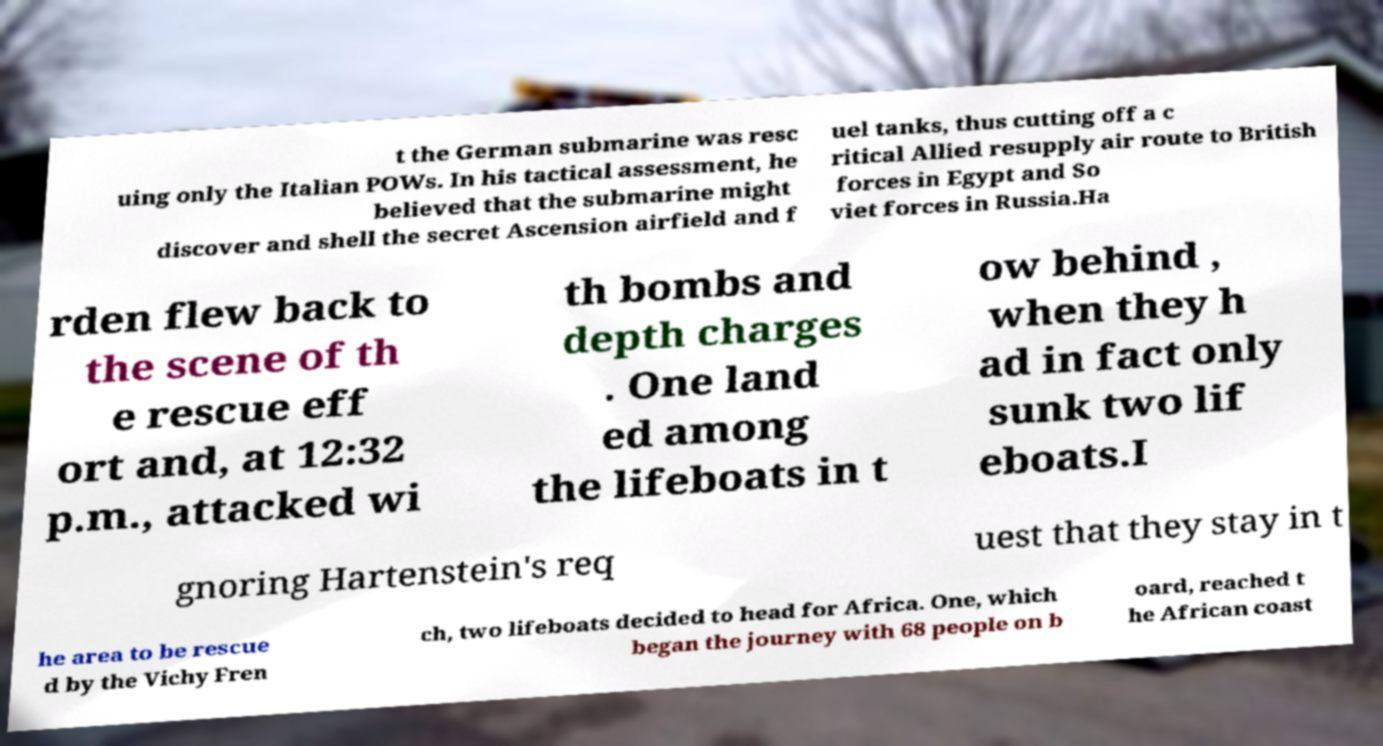Can you read and provide the text displayed in the image?This photo seems to have some interesting text. Can you extract and type it out for me? t the German submarine was resc uing only the Italian POWs. In his tactical assessment, he believed that the submarine might discover and shell the secret Ascension airfield and f uel tanks, thus cutting off a c ritical Allied resupply air route to British forces in Egypt and So viet forces in Russia.Ha rden flew back to the scene of th e rescue eff ort and, at 12:32 p.m., attacked wi th bombs and depth charges . One land ed among the lifeboats in t ow behind , when they h ad in fact only sunk two lif eboats.I gnoring Hartenstein's req uest that they stay in t he area to be rescue d by the Vichy Fren ch, two lifeboats decided to head for Africa. One, which began the journey with 68 people on b oard, reached t he African coast 